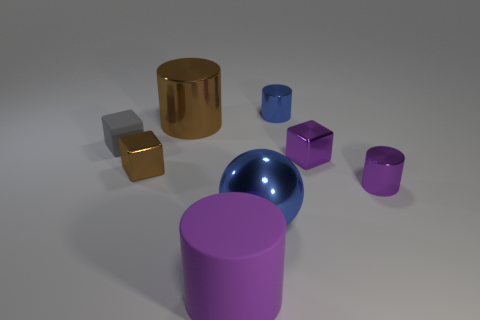There is a large rubber cylinder; is its color the same as the block that is to the right of the metal ball?
Keep it short and to the point. Yes. Is the material of the purple cube the same as the large purple object?
Provide a succinct answer. No. There is a block on the right side of the brown metallic block; what number of brown metallic objects are behind it?
Provide a succinct answer. 1. There is a tiny cylinder in front of the big metallic cylinder; is it the same color as the rubber cylinder?
Your response must be concise. Yes. How many things are large blue spheres or tiny purple objects that are in front of the small purple shiny block?
Your answer should be compact. 2. Is the shape of the blue metallic object that is behind the gray matte object the same as the blue thing that is on the left side of the tiny blue object?
Your answer should be very brief. No. Is there anything else that is the same color as the small rubber cube?
Your answer should be compact. No. What is the shape of the tiny brown object that is made of the same material as the large blue ball?
Your answer should be compact. Cube. What is the material of the large thing that is both in front of the gray rubber cube and left of the large blue object?
Ensure brevity in your answer.  Rubber. The small object that is the same color as the big ball is what shape?
Offer a very short reply. Cylinder. 